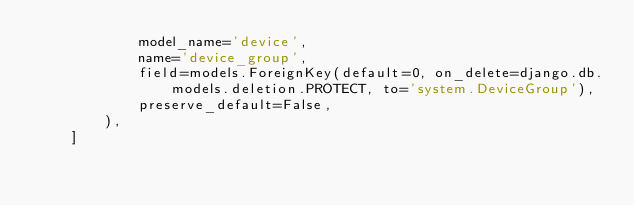Convert code to text. <code><loc_0><loc_0><loc_500><loc_500><_Python_>            model_name='device',
            name='device_group',
            field=models.ForeignKey(default=0, on_delete=django.db.models.deletion.PROTECT, to='system.DeviceGroup'),
            preserve_default=False,
        ),
    ]
</code> 